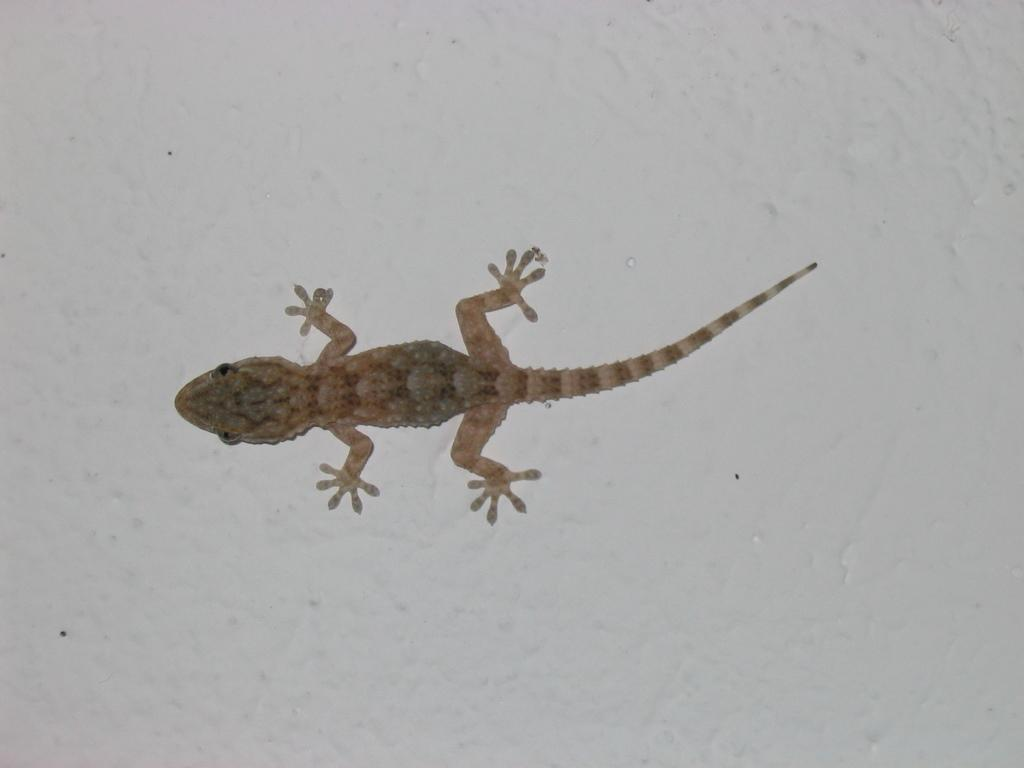What type of animal is in the image? There is a lizard in the image. What color is the lizard? The lizard is brown in color. What is the color of the background in the image? The background of the image is white. What type of faucet can be seen in the image? There is no faucet present in the image; it features a lizard on a white background. What type of clouds are visible in the image? There are no clouds visible in the image; it features a lizard on a white background. 